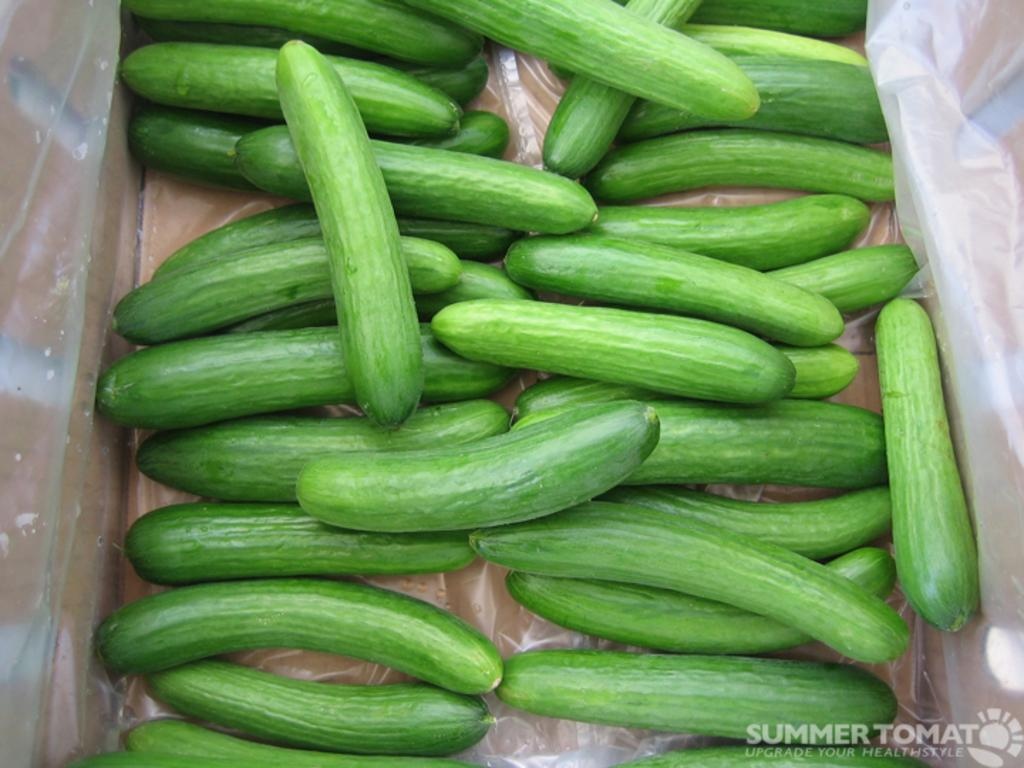What type of vegetable is present in the image? There are cucumbers in the image. What is covering or protecting something in the image? There is a cover in the image. What type of rail can be seen in the image? There is no rail present in the image. What kind of pet is visible in the image? There are no pets visible in the image. Is there a baby present in the image? There is no baby present in the image. 